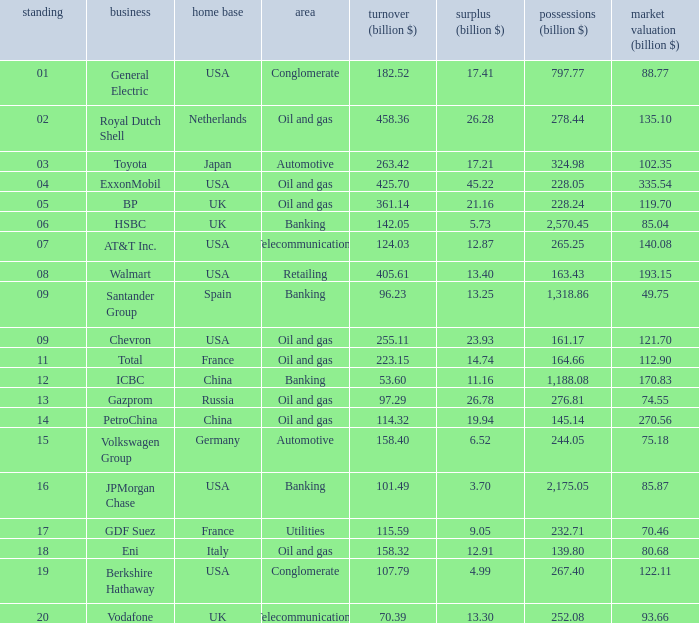Name the highest Profits (billion $) which has a Company of walmart? 13.4. I'm looking to parse the entire table for insights. Could you assist me with that? {'header': ['standing', 'business', 'home base', 'area', 'turnover (billion $)', 'surplus (billion $)', 'possessions (billion $)', 'market valuation (billion $)'], 'rows': [['01', 'General Electric', 'USA', 'Conglomerate', '182.52', '17.41', '797.77', '88.77'], ['02', 'Royal Dutch Shell', 'Netherlands', 'Oil and gas', '458.36', '26.28', '278.44', '135.10'], ['03', 'Toyota', 'Japan', 'Automotive', '263.42', '17.21', '324.98', '102.35'], ['04', 'ExxonMobil', 'USA', 'Oil and gas', '425.70', '45.22', '228.05', '335.54'], ['05', 'BP', 'UK', 'Oil and gas', '361.14', '21.16', '228.24', '119.70'], ['06', 'HSBC', 'UK', 'Banking', '142.05', '5.73', '2,570.45', '85.04'], ['07', 'AT&T Inc.', 'USA', 'Telecommunications', '124.03', '12.87', '265.25', '140.08'], ['08', 'Walmart', 'USA', 'Retailing', '405.61', '13.40', '163.43', '193.15'], ['09', 'Santander Group', 'Spain', 'Banking', '96.23', '13.25', '1,318.86', '49.75'], ['09', 'Chevron', 'USA', 'Oil and gas', '255.11', '23.93', '161.17', '121.70'], ['11', 'Total', 'France', 'Oil and gas', '223.15', '14.74', '164.66', '112.90'], ['12', 'ICBC', 'China', 'Banking', '53.60', '11.16', '1,188.08', '170.83'], ['13', 'Gazprom', 'Russia', 'Oil and gas', '97.29', '26.78', '276.81', '74.55'], ['14', 'PetroChina', 'China', 'Oil and gas', '114.32', '19.94', '145.14', '270.56'], ['15', 'Volkswagen Group', 'Germany', 'Automotive', '158.40', '6.52', '244.05', '75.18'], ['16', 'JPMorgan Chase', 'USA', 'Banking', '101.49', '3.70', '2,175.05', '85.87'], ['17', 'GDF Suez', 'France', 'Utilities', '115.59', '9.05', '232.71', '70.46'], ['18', 'Eni', 'Italy', 'Oil and gas', '158.32', '12.91', '139.80', '80.68'], ['19', 'Berkshire Hathaway', 'USA', 'Conglomerate', '107.79', '4.99', '267.40', '122.11'], ['20', 'Vodafone', 'UK', 'Telecommunications', '70.39', '13.30', '252.08', '93.66']]} 